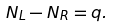<formula> <loc_0><loc_0><loc_500><loc_500>N _ { L } - N _ { R } = q .</formula> 